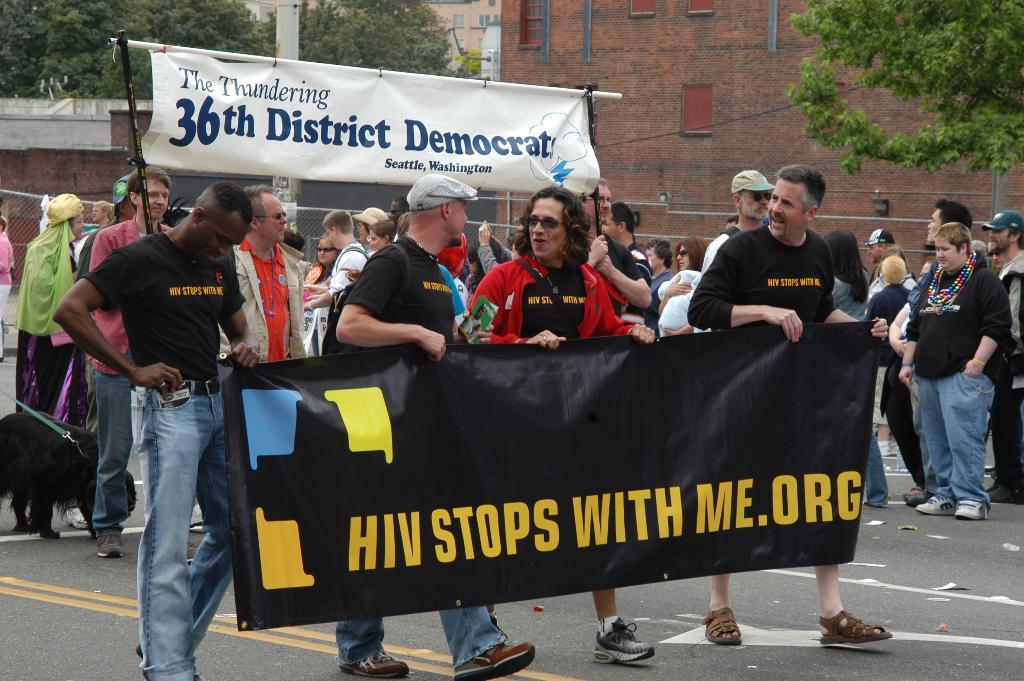Please provide a concise description of this image. In this image in the front of there are persons holding banner with some text written on it and walking. In the background there are persons, there is a banner with some text and numbers written on it, there are trees and buildings and there is a net. 